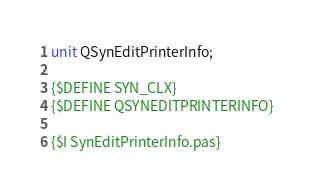<code> <loc_0><loc_0><loc_500><loc_500><_Pascal_>unit QSynEditPrinterInfo;

{$DEFINE SYN_CLX}
{$DEFINE QSYNEDITPRINTERINFO}

{$I SynEditPrinterInfo.pas}
</code> 